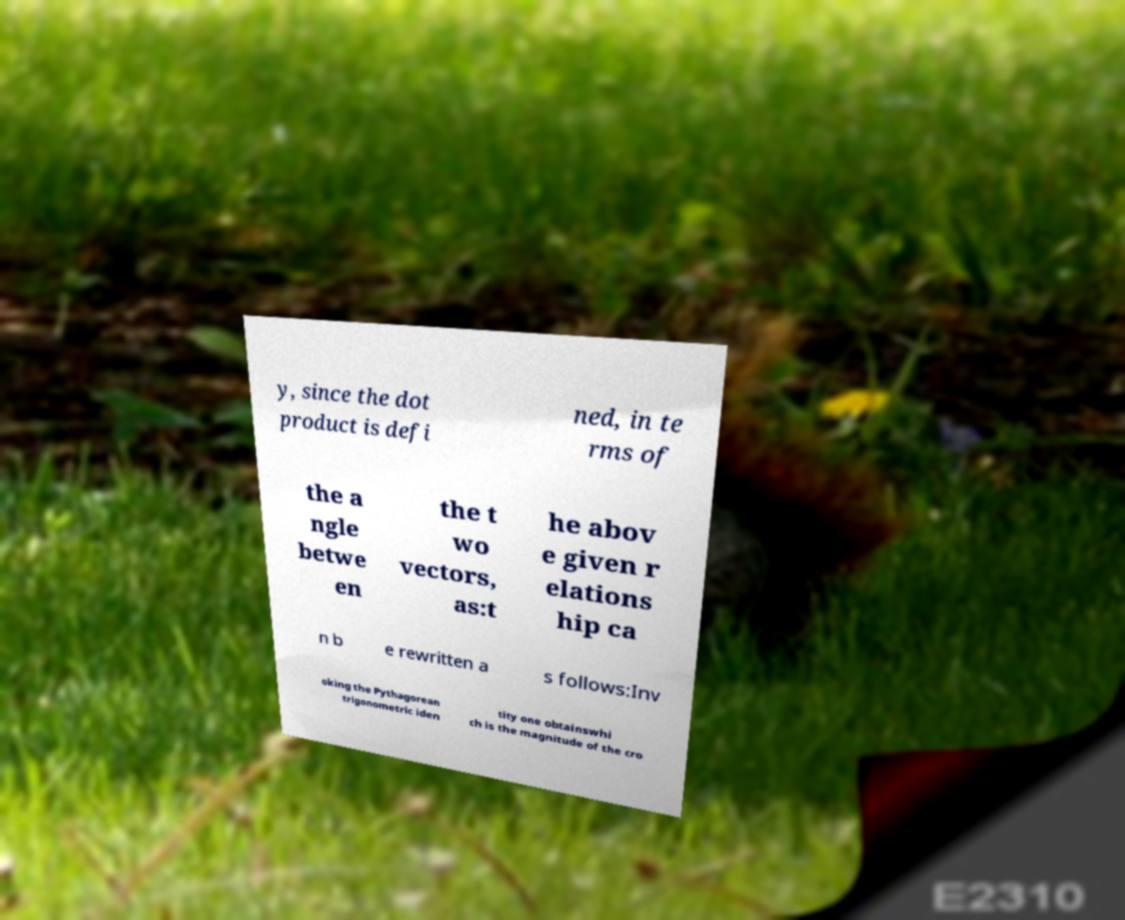Could you extract and type out the text from this image? y, since the dot product is defi ned, in te rms of the a ngle betwe en the t wo vectors, as:t he abov e given r elations hip ca n b e rewritten a s follows:Inv oking the Pythagorean trigonometric iden tity one obtainswhi ch is the magnitude of the cro 